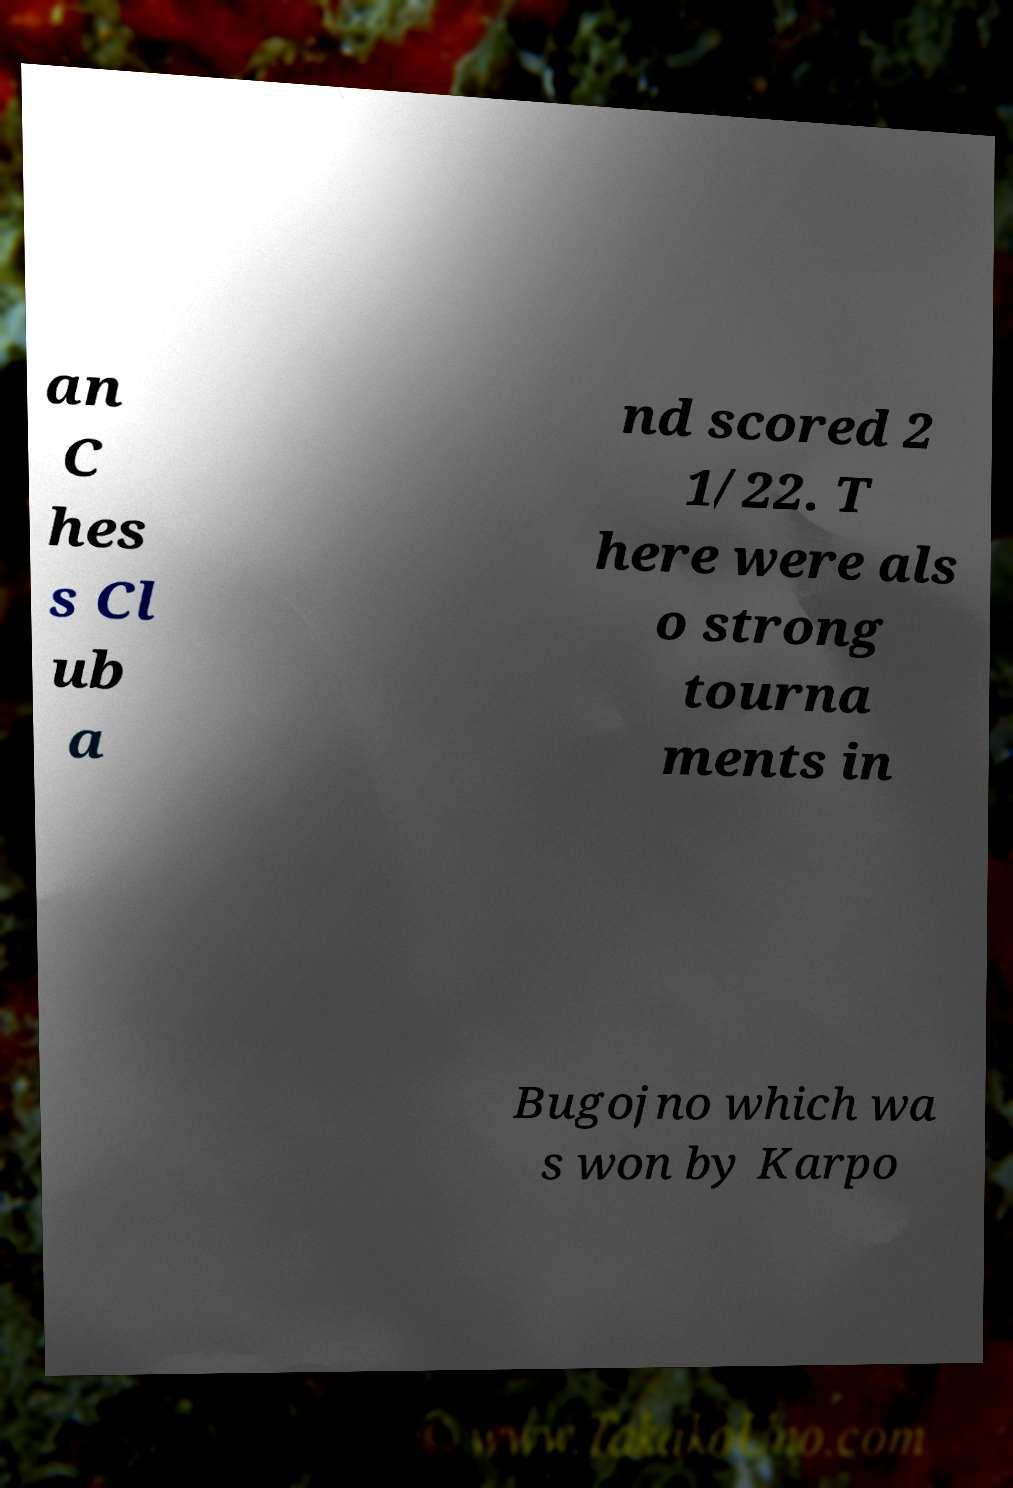What messages or text are displayed in this image? I need them in a readable, typed format. an C hes s Cl ub a nd scored 2 1/22. T here were als o strong tourna ments in Bugojno which wa s won by Karpo 